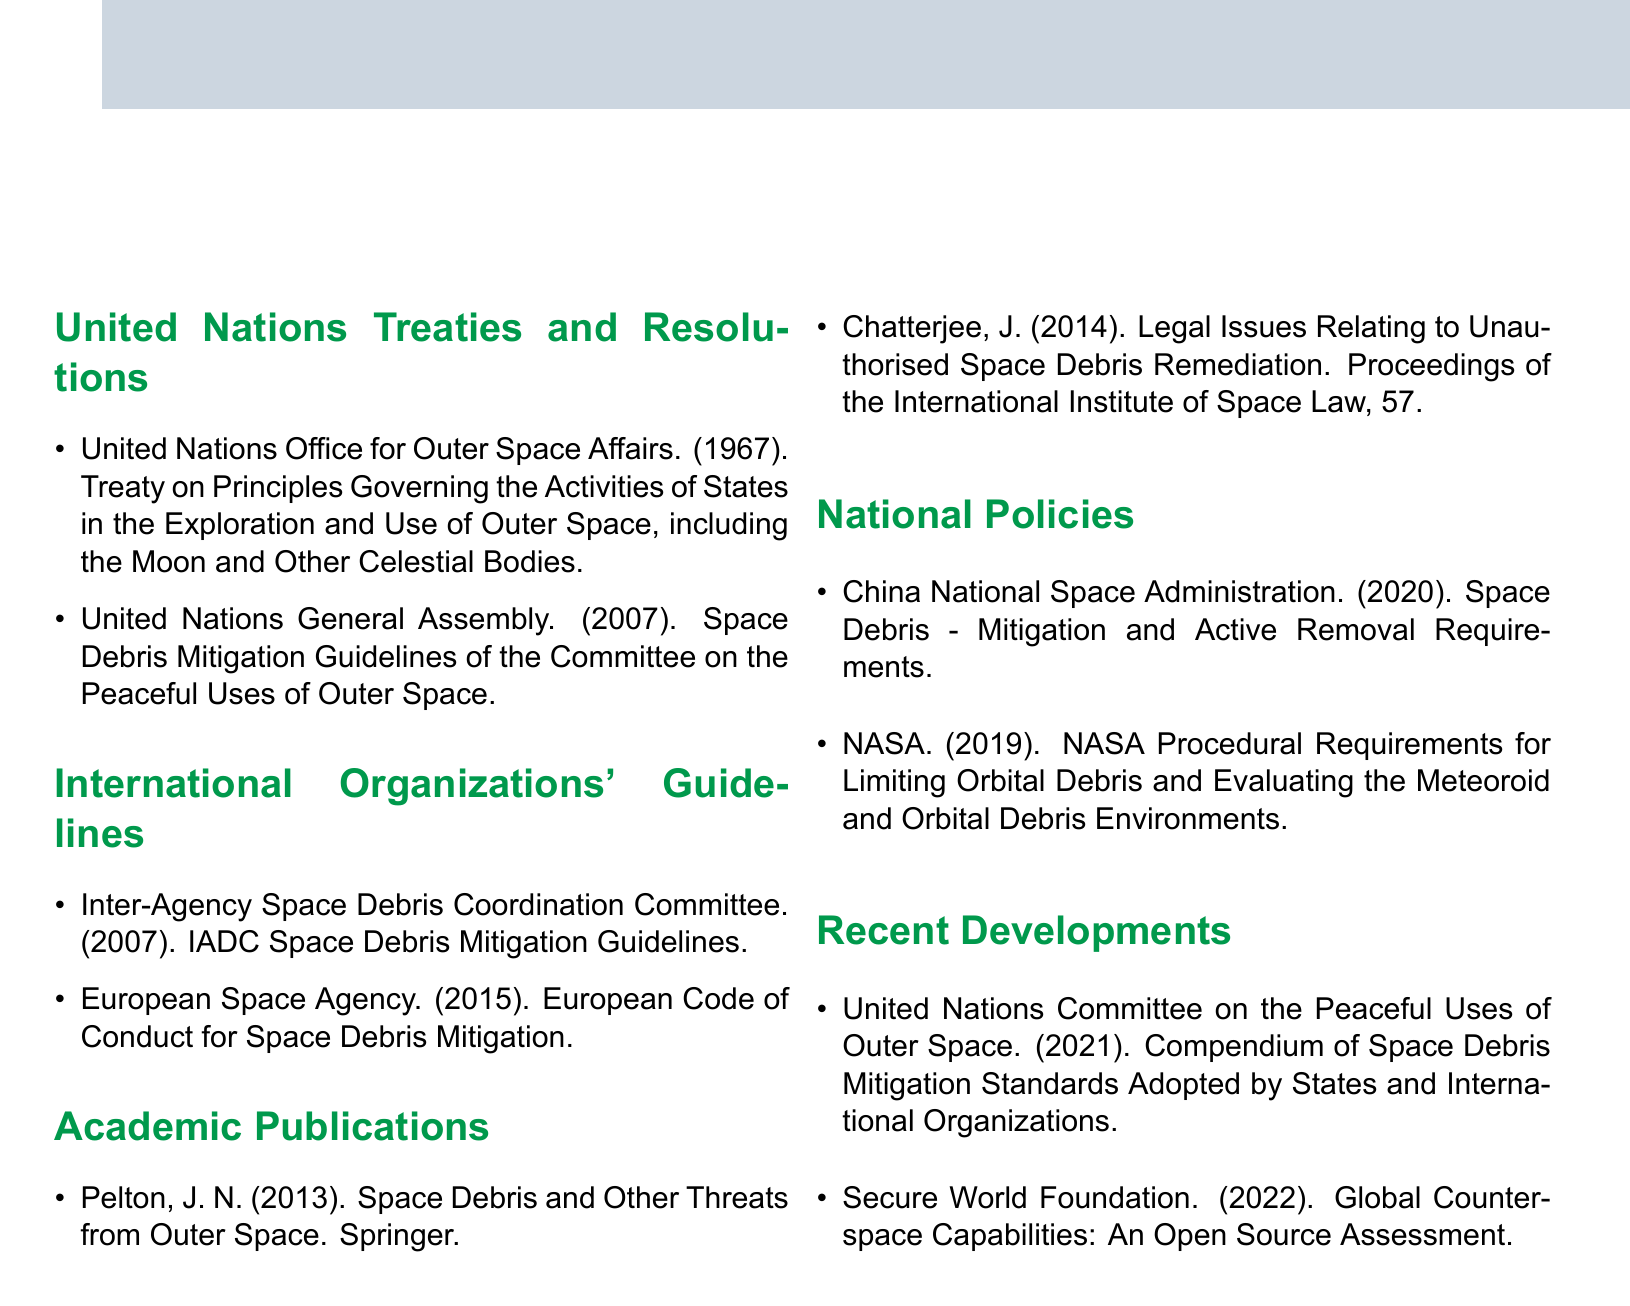What year was the Treaty on Principles Governing the Activities of States in the Exploration and Use of Outer Space established? The document lists the year 1967 next to the treaty title.
Answer: 1967 Which organization published the Space Debris Mitigation Guidelines in 2007? The guidelines are attributed to the United Nations General Assembly in the document.
Answer: United Nations General Assembly What is the title of the publication by the Inter-Agency Space Debris Coordination Committee? The document states the title as "IADC Space Debris Mitigation Guidelines."
Answer: IADC Space Debris Mitigation Guidelines How many recent developments are listed in the document? The document includes a section titled "Recent Developments" which cites two publications.
Answer: 2 What is the publication year of "Space Debris - Mitigation and Active Removal Requirements"? The document states that the China National Space Administration published it in 2020.
Answer: 2020 Who authored "Legal Issues Relating to Unauthorised Space Debris Remediation"? The document provides the author's name as J. Chatterjee.
Answer: J. Chatterjee Which organization issued national procedural requirements for limiting orbital debris in 2019? The document attributes the procedural requirements to NASA.
Answer: NASA What color is used for the section titles in the document? The document describes the color for section titles as earthgreen.
Answer: earthgreen 